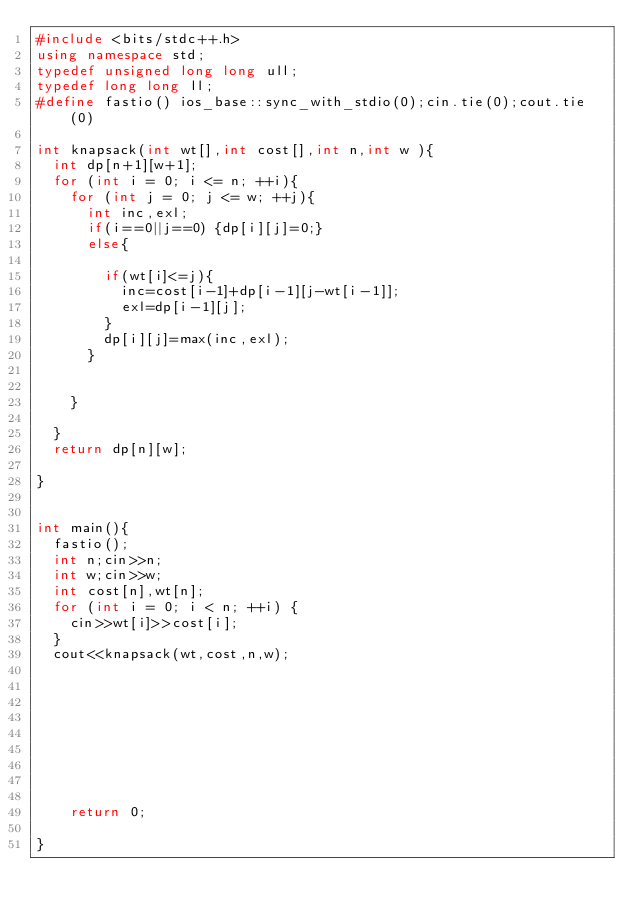<code> <loc_0><loc_0><loc_500><loc_500><_C++_>#include <bits/stdc++.h>
using namespace std;
typedef unsigned long long ull;
typedef long long ll;
#define fastio() ios_base::sync_with_stdio(0);cin.tie(0);cout.tie(0)

int knapsack(int wt[],int cost[],int n,int w ){
	int dp[n+1][w+1];
	for (int i = 0; i <= n; ++i){ 
		for (int j = 0; j <= w; ++j){ 
			int inc,exl;
			if(i==0||j==0) {dp[i][j]=0;}
			else{ 
				
				if(wt[i]<=j){
					inc=cost[i-1]+dp[i-1][j-wt[i-1]];
					exl=dp[i-1][j];
				}
				dp[i][j]=max(inc,exl);
			}

			
		}

	}
	return dp[n][w];

}


int main(){
	fastio();
	int n;cin>>n;
	int w;cin>>w;
	int cost[n],wt[n];
	for (int i = 0; i < n; ++i) { 
		cin>>wt[i]>>cost[i];
	}
	cout<<knapsack(wt,cost,n,w);

	







    return 0;
	
}</code> 